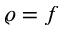Convert formula to latex. <formula><loc_0><loc_0><loc_500><loc_500>\varrho = f</formula> 